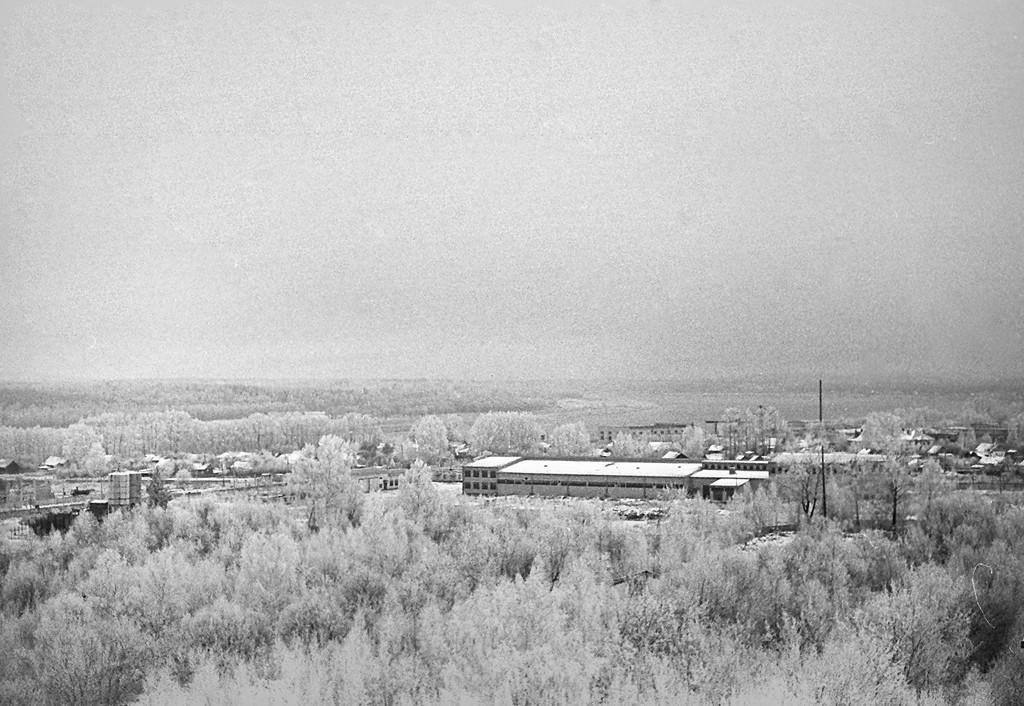What type of natural elements can be seen in the image? There are trees in the image. What type of man-made structures are present in the image? There are buildings in the image. What is the color scheme of the image? The image is black and white in color. Where is the mailbox located in the image? There is no mailbox present in the image. What type of apparel are the trees wearing in the image? Trees do not wear apparel, as they are natural elements and not human-like beings. 